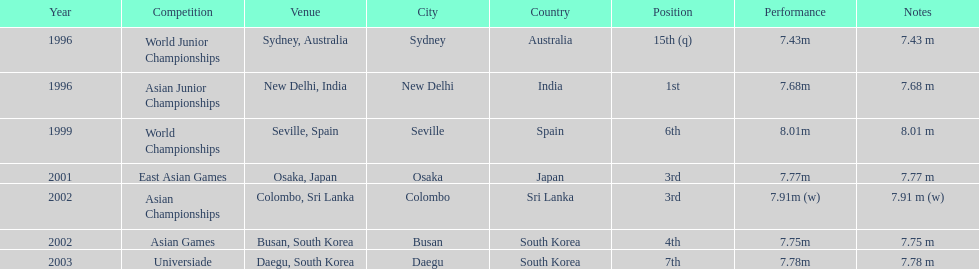What was the only competition where this competitor achieved 1st place? Asian Junior Championships. 